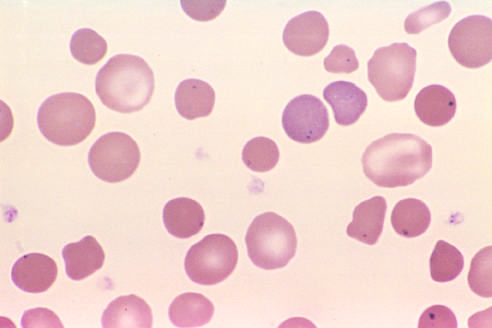what are also present in the red cells of this asplenic patient?
Answer the question using a single word or phrase. Howell-jolly bodies (small nuclear remnants) 